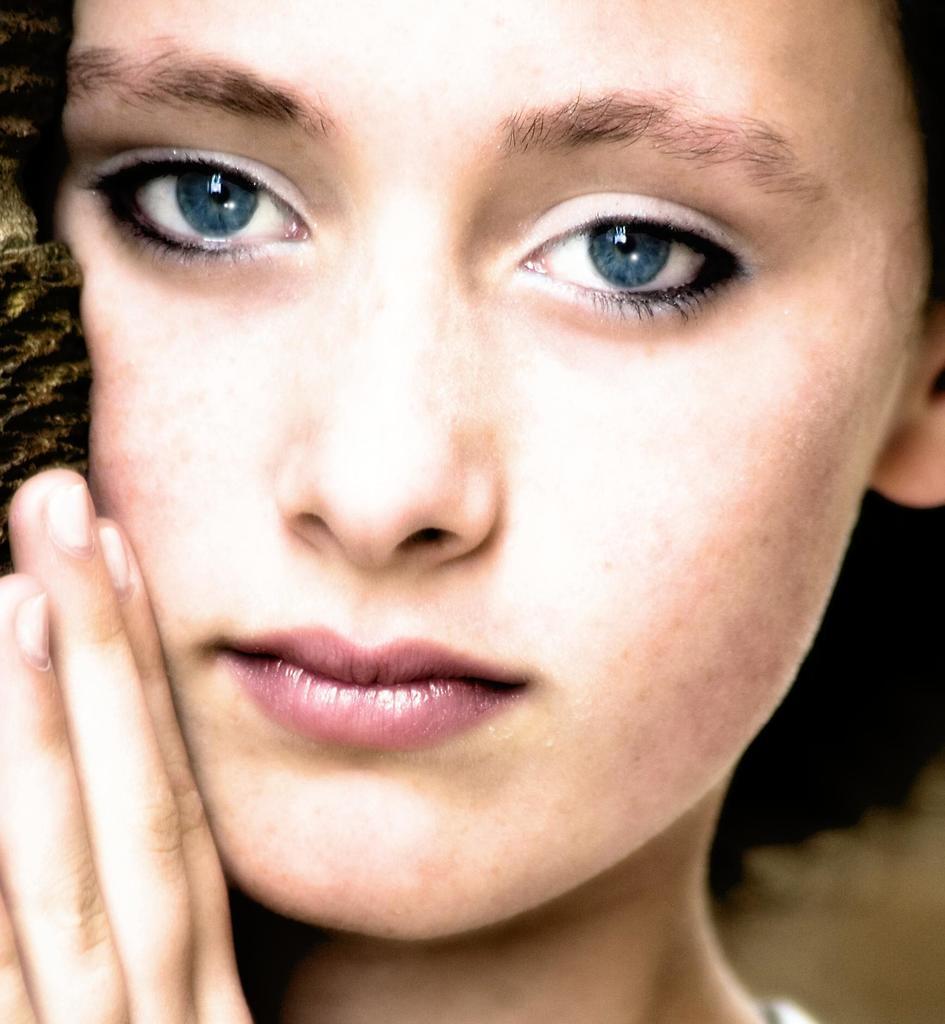Could you give a brief overview of what you see in this image? In this image, we can see a woman touching an object in her hand. 